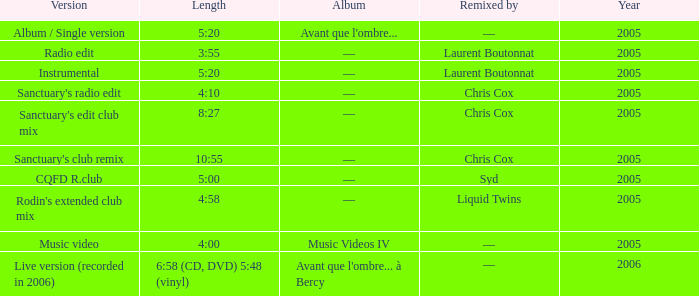What is the version presented for the length of 5:20, and reveals remixed by —? Album / Single version. 